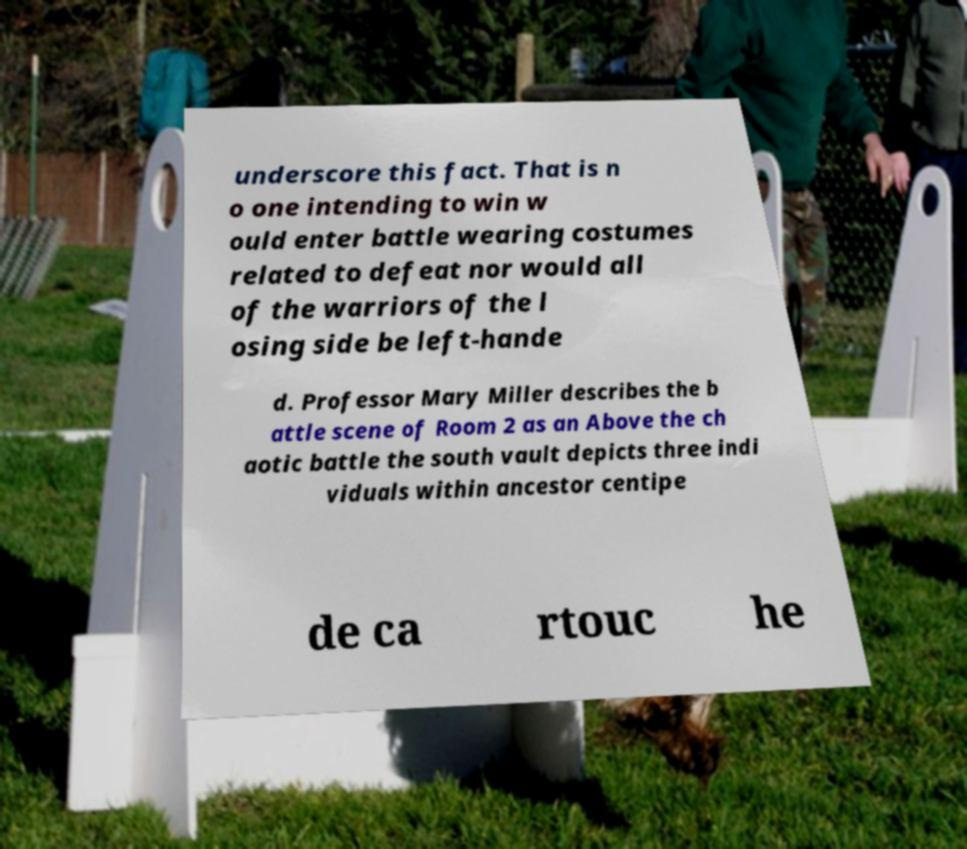Can you accurately transcribe the text from the provided image for me? underscore this fact. That is n o one intending to win w ould enter battle wearing costumes related to defeat nor would all of the warriors of the l osing side be left-hande d. Professor Mary Miller describes the b attle scene of Room 2 as an Above the ch aotic battle the south vault depicts three indi viduals within ancestor centipe de ca rtouc he 